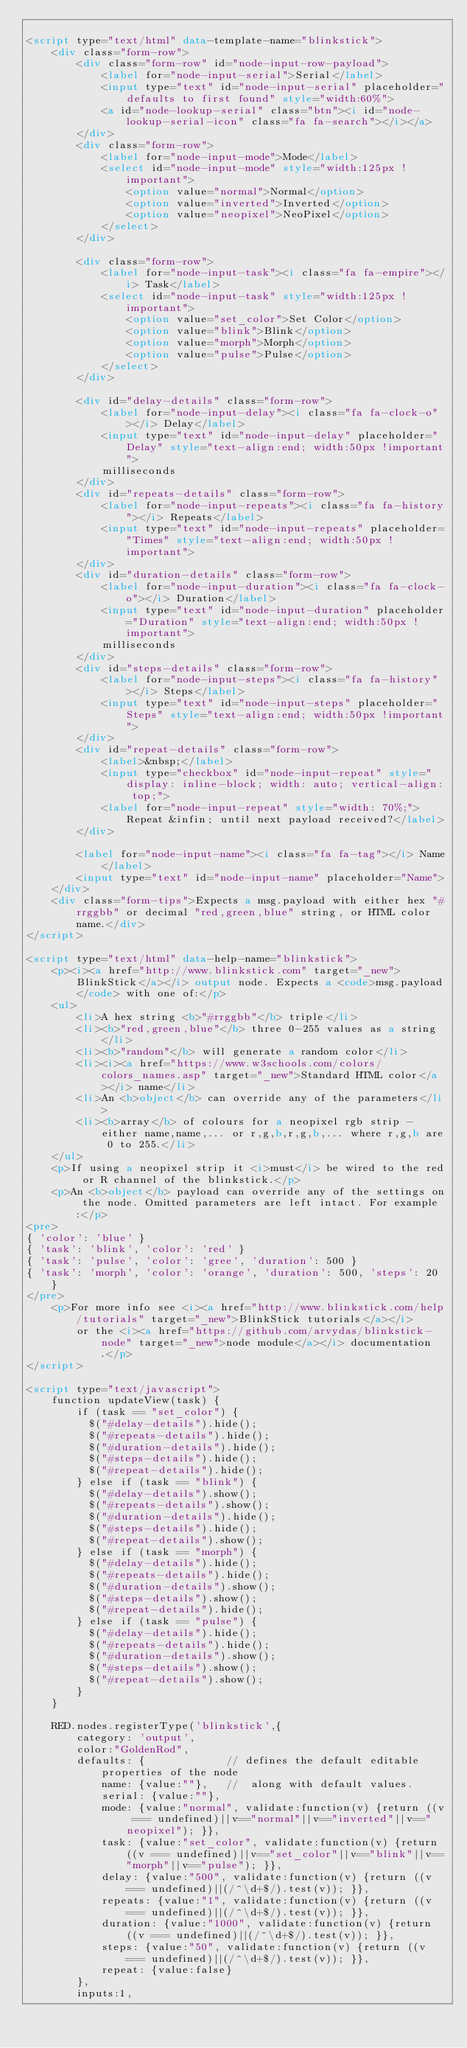<code> <loc_0><loc_0><loc_500><loc_500><_HTML_>
<script type="text/html" data-template-name="blinkstick">
    <div class="form-row">
        <div class="form-row" id="node-input-row-payload">
            <label for="node-input-serial">Serial</label>
            <input type="text" id="node-input-serial" placeholder="defaults to first found" style="width:60%">
            <a id="node-lookup-serial" class="btn"><i id="node-lookup-serial-icon" class="fa fa-search"></i></a>
        </div>
        <div class="form-row">
            <label for="node-input-mode">Mode</label>
            <select id="node-input-mode" style="width:125px !important">
                <option value="normal">Normal</option>
                <option value="inverted">Inverted</option>
                <option value="neopixel">NeoPixel</option>
            </select>
        </div>

        <div class="form-row">
            <label for="node-input-task"><i class="fa fa-empire"></i> Task</label>
            <select id="node-input-task" style="width:125px !important">
                <option value="set_color">Set Color</option>
                <option value="blink">Blink</option>
                <option value="morph">Morph</option>
                <option value="pulse">Pulse</option>
            </select>
        </div>

        <div id="delay-details" class="form-row">
            <label for="node-input-delay"><i class="fa fa-clock-o"></i> Delay</label>
            <input type="text" id="node-input-delay" placeholder="Delay" style="text-align:end; width:50px !important">
            milliseconds
        </div>
        <div id="repeats-details" class="form-row">
            <label for="node-input-repeats"><i class="fa fa-history"></i> Repeats</label>
            <input type="text" id="node-input-repeats" placeholder="Times" style="text-align:end; width:50px !important">
        </div>
        <div id="duration-details" class="form-row">
            <label for="node-input-duration"><i class="fa fa-clock-o"></i> Duration</label>
            <input type="text" id="node-input-duration" placeholder="Duration" style="text-align:end; width:50px !important">
            milliseconds
        </div>
        <div id="steps-details" class="form-row">
            <label for="node-input-steps"><i class="fa fa-history"></i> Steps</label>
            <input type="text" id="node-input-steps" placeholder="Steps" style="text-align:end; width:50px !important">
        </div>
        <div id="repeat-details" class="form-row">
            <label>&nbsp;</label>
            <input type="checkbox" id="node-input-repeat" style="display: inline-block; width: auto; vertical-align: top;">
            <label for="node-input-repeat" style="width: 70%;">Repeat &infin; until next payload received?</label>
        </div>

        <label for="node-input-name"><i class="fa fa-tag"></i> Name</label>
        <input type="text" id="node-input-name" placeholder="Name">
    </div>
    <div class="form-tips">Expects a msg.payload with either hex "#rrggbb" or decimal "red,green,blue" string, or HTML color name.</div>
</script>

<script type="text/html" data-help-name="blinkstick">
    <p><i><a href="http://www.blinkstick.com" target="_new">BlinkStick</a></i> output node. Expects a <code>msg.payload</code> with one of:</p>
    <ul>
        <li>A hex string <b>"#rrggbb"</b> triple</li>
        <li><b>"red,green,blue"</b> three 0-255 values as a string</li>
        <li><b>"random"</b> will generate a random color</li>
        <li><i><a href="https://www.w3schools.com/colors/colors_names.asp" target="_new">Standard HTML color</a></i> name</li>
        <li>An <b>object</b> can override any of the parameters</li>
        <li><b>array</b> of colours for a neopixel rgb strip - either name,name,... or r,g,b,r,g,b,... where r,g,b are 0 to 255.</li>
    </ul>
    <p>If using a neopixel strip it <i>must</i> be wired to the red or R channel of the blinkstick.</p>
    <p>An <b>object</b> payload can override any of the settings on the node. Omitted parameters are left intact. For example:</p>
<pre>
{ 'color': 'blue' }
{ 'task': 'blink', 'color': 'red' }
{ 'task': 'pulse', 'color': 'gree', 'duration': 500 }
{ 'task': 'morph', 'color': 'orange', 'duration': 500, 'steps': 20 }
</pre>
    <p>For more info see <i><a href="http://www.blinkstick.com/help/tutorials" target="_new">BlinkStick tutorials</a></i>
        or the <i><a href="https://github.com/arvydas/blinkstick-node" target="_new">node module</a></i> documentation.</p>
</script>

<script type="text/javascript">
    function updateView(task) {
        if (task == "set_color") {
          $("#delay-details").hide();
          $("#repeats-details").hide();
          $("#duration-details").hide();
          $("#steps-details").hide();
          $("#repeat-details").hide();
        } else if (task == "blink") {
          $("#delay-details").show();
          $("#repeats-details").show();
          $("#duration-details").hide();
          $("#steps-details").hide();
          $("#repeat-details").show();
        } else if (task == "morph") {
          $("#delay-details").hide();
          $("#repeats-details").hide();
          $("#duration-details").show();
          $("#steps-details").show();
          $("#repeat-details").hide();
        } else if (task == "pulse") {
          $("#delay-details").hide();
          $("#repeats-details").hide();
          $("#duration-details").show();
          $("#steps-details").show();
          $("#repeat-details").show();
        }
    }

    RED.nodes.registerType('blinkstick',{
        category: 'output',
        color:"GoldenRod",
        defaults: {             // defines the default editable properties of the node
            name: {value:""},   //  along with default values.
            serial: {value:""},
            mode: {value:"normal", validate:function(v) {return ((v === undefined)||v=="normal"||v=="inverted"||v=="neopixel"); }},
            task: {value:"set_color", validate:function(v) {return ((v === undefined)||v=="set_color"||v=="blink"||v=="morph"||v=="pulse"); }},
            delay: {value:"500", validate:function(v) {return ((v === undefined)||(/^\d+$/).test(v)); }},
            repeats: {value:"1", validate:function(v) {return ((v === undefined)||(/^\d+$/).test(v)); }},
            duration: {value:"1000", validate:function(v) {return ((v === undefined)||(/^\d+$/).test(v)); }},
            steps: {value:"50", validate:function(v) {return ((v === undefined)||(/^\d+$/).test(v)); }},
            repeat: {value:false}
        },
        inputs:1,</code> 